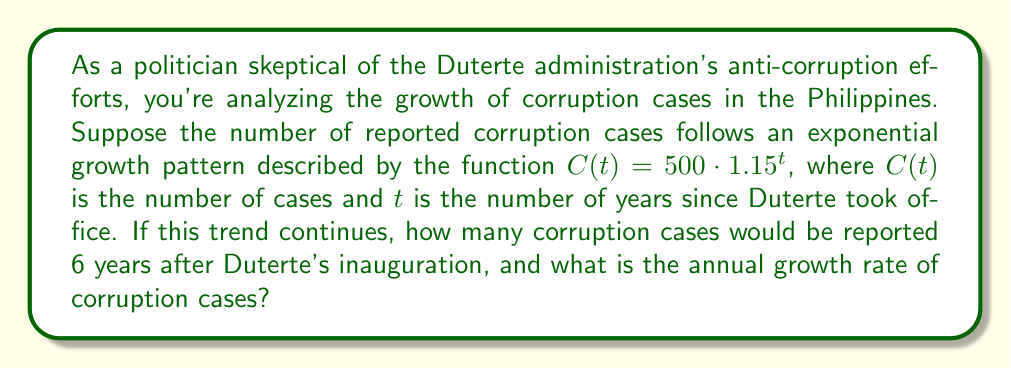Show me your answer to this math problem. To solve this problem, we need to use the given exponential function and understand its components:

1. $C(t) = 500 \cdot 1.15^t$
   - 500 is the initial number of cases
   - 1.15 is the growth factor
   - $t$ is the number of years since Duterte took office

2. To find the number of cases after 6 years, we substitute $t = 6$ into the function:
   $C(6) = 500 \cdot 1.15^6$

3. Calculate $1.15^6$:
   $1.15^6 \approx 2.3131$

4. Multiply by the initial number:
   $500 \cdot 2.3131 \approx 1156.55$

5. Round to the nearest whole number, as we can't have fractional cases:
   1157 cases

6. To find the annual growth rate, we need to understand that in an exponential function $a \cdot b^t$, $(b - 1) \cdot 100\%$ gives the percentage increase.

7. In this case, $b = 1.15$, so:
   $(1.15 - 1) \cdot 100\% = 0.15 \cdot 100\% = 15\%$

Therefore, the annual growth rate is 15%.
Answer: After 6 years, there would be approximately 1157 reported corruption cases. The annual growth rate of corruption cases is 15%. 